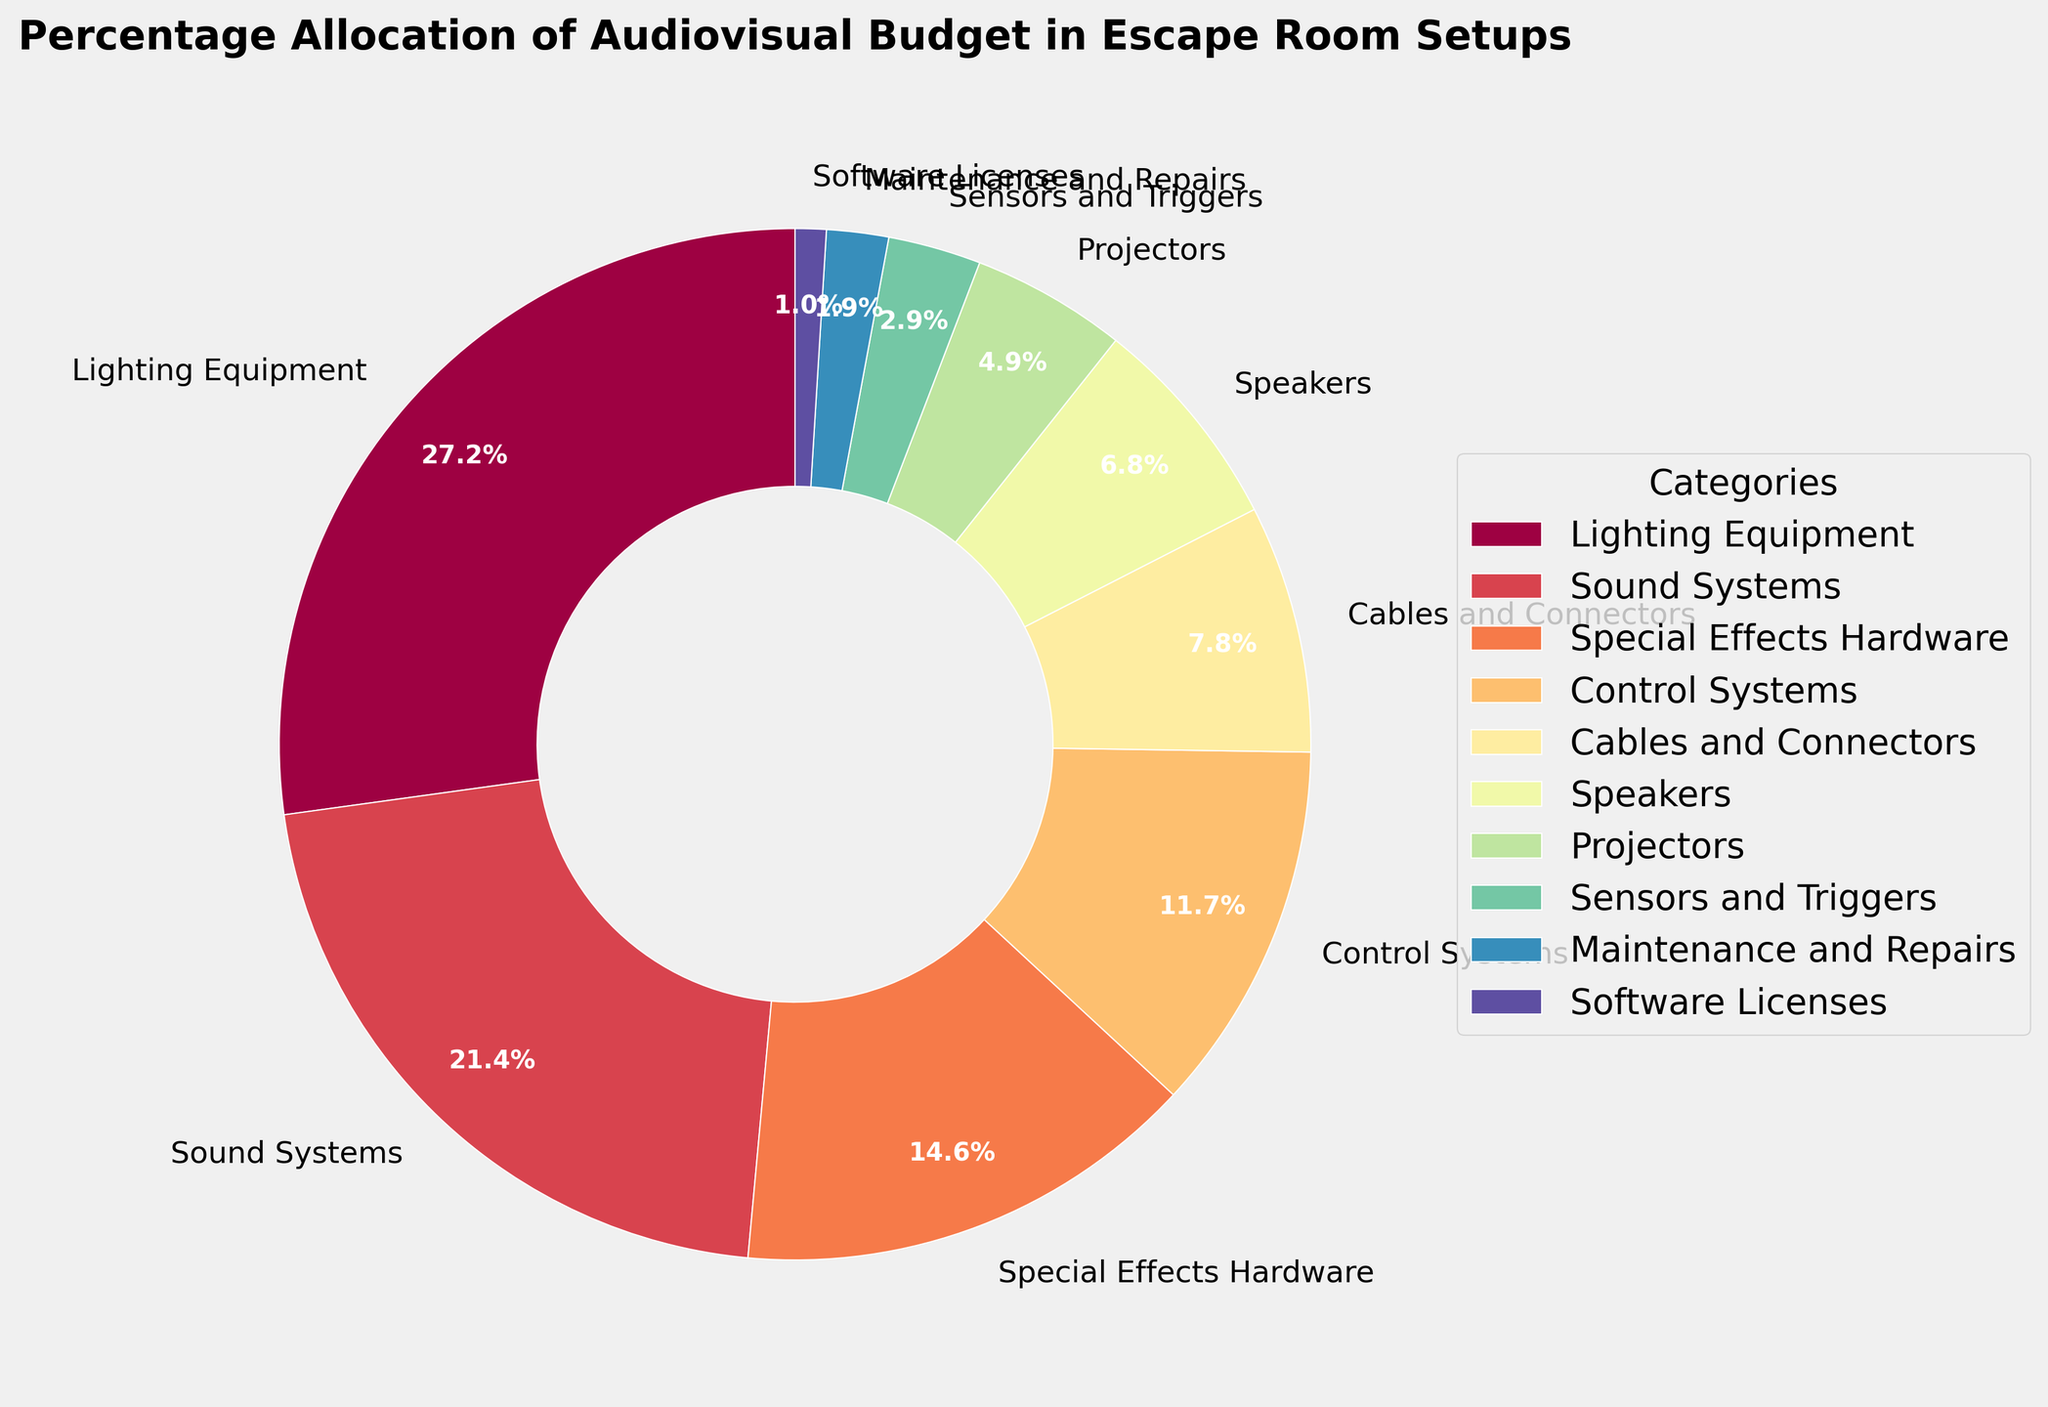Which category has the highest budget allocation? Looking at the pie chart, the largest wedge represents the category with the highest budget allocation.
Answer: Lighting Equipment What is the combined percentage allocation for Sound Systems and Special Effects Hardware? To find the combined allocation, simply add the percentages of Sound Systems (22%) and Special Effects Hardware (15%). Thus, 22% + 15% = 37%.
Answer: 37% Which category has a greater budget allocation, Projectors or Cables and Connectors? By comparing the percentages from the pie chart, Projectors (5%) is lower than Cables and Connectors (8%).
Answer: Cables and Connectors What is the total percentage of budget allocations for categories under 5%? Add the percentages for Projectors (5%), Sensors and Triggers (3%), Maintenance and Repairs (2%), and Software Licenses (1%). Thus, 5% + 3% + 2% + 1% = 11%.
Answer: 11% Between Special Effects Hardware and Control Systems, which has a smaller wedge in the pie chart? Look at the sizes of the wedges; Control Systems (12%) is smaller than Special Effects Hardware (15%).
Answer: Control Systems State the budget allocation difference between Lighting Equipment and Sound Systems. Subtract the percentage of Sound Systems (22%) from Lighting Equipment (28%). Thus, 28% - 22% = 6%.
Answer: 6% What is the percentage allocation of categories related to sound (Speakers and Sound Systems)? Add the percentages for Speakers (7%) and Sound Systems (22%) together. Thus, 7% + 22% = 29%.
Answer: 29% How does the budget allocation for Sensors and Triggers compare with Maintenance and Repairs? Sensors and Triggers have a budget allocation of 3%, which is larger compared to Maintenance and Repairs, which have an allocation of 2%.
Answer: Sensors and Triggers Which categories constitute the smallest three allocations combined, and what is their total percentage? The smallest three allocations are Maintenance and Repairs (2%), Software Licenses (1%), and Sensors and Triggers (3%). Their combined percentage is 2% + 1% + 3% = 6%.
Answer: Maintenance and Repairs, Software Licenses, Sensors and Triggers; 6% How does the percentage allocation for Control Systems compare to the average allocation of the top two categories? The top two categories are Lighting Equipment (28%) and Sound Systems (22%). The average of these two is (28% + 22%) / 2 = 25%. Control Systems have an allocation of 12%, which is less than the average of 25%.
Answer: Less than; 12% compared to 25% 